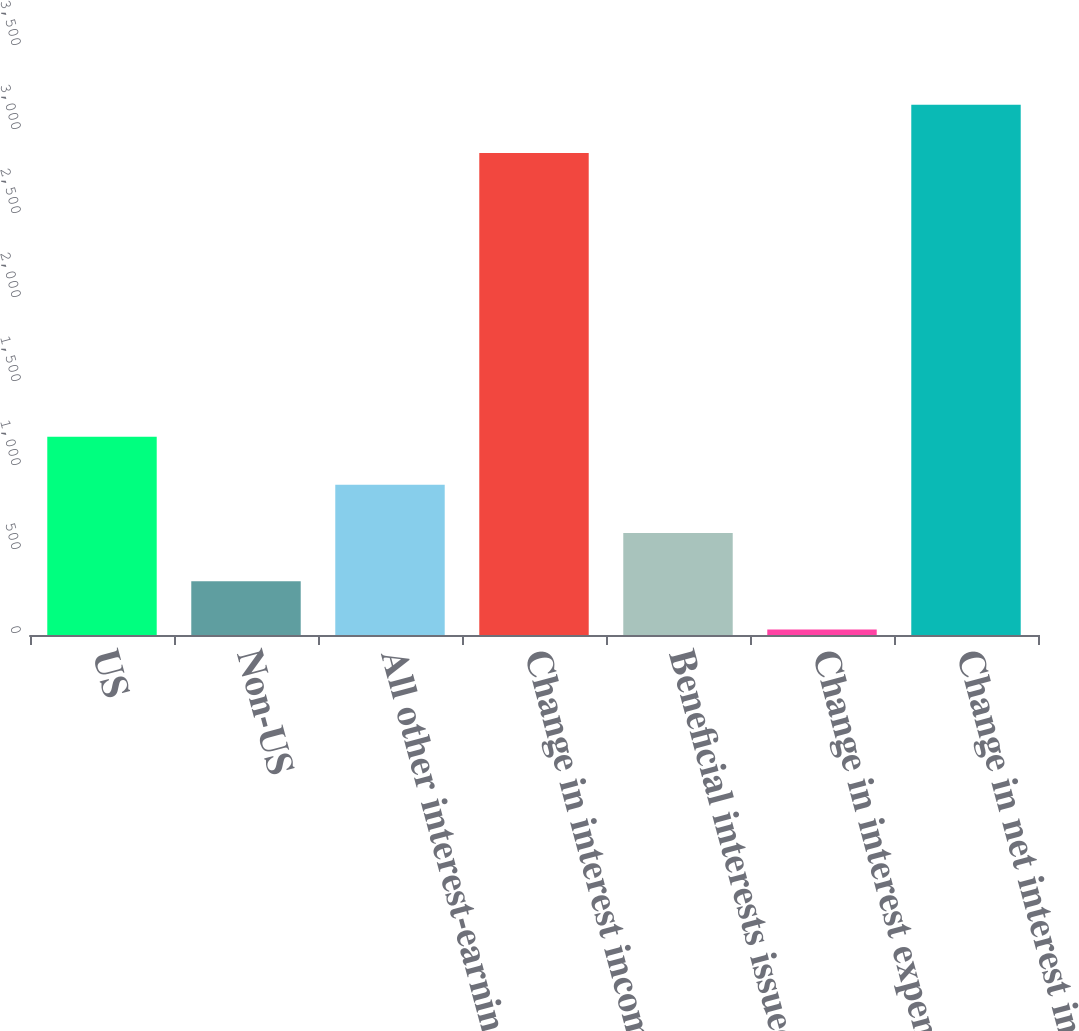Convert chart. <chart><loc_0><loc_0><loc_500><loc_500><bar_chart><fcel>US<fcel>Non-US<fcel>All other interest-earning<fcel>Change in interest income<fcel>Beneficial interests issued by<fcel>Change in interest expense<fcel>Change in net interest income<nl><fcel>1180.6<fcel>319.9<fcel>893.7<fcel>2869<fcel>606.8<fcel>33<fcel>3155.9<nl></chart> 